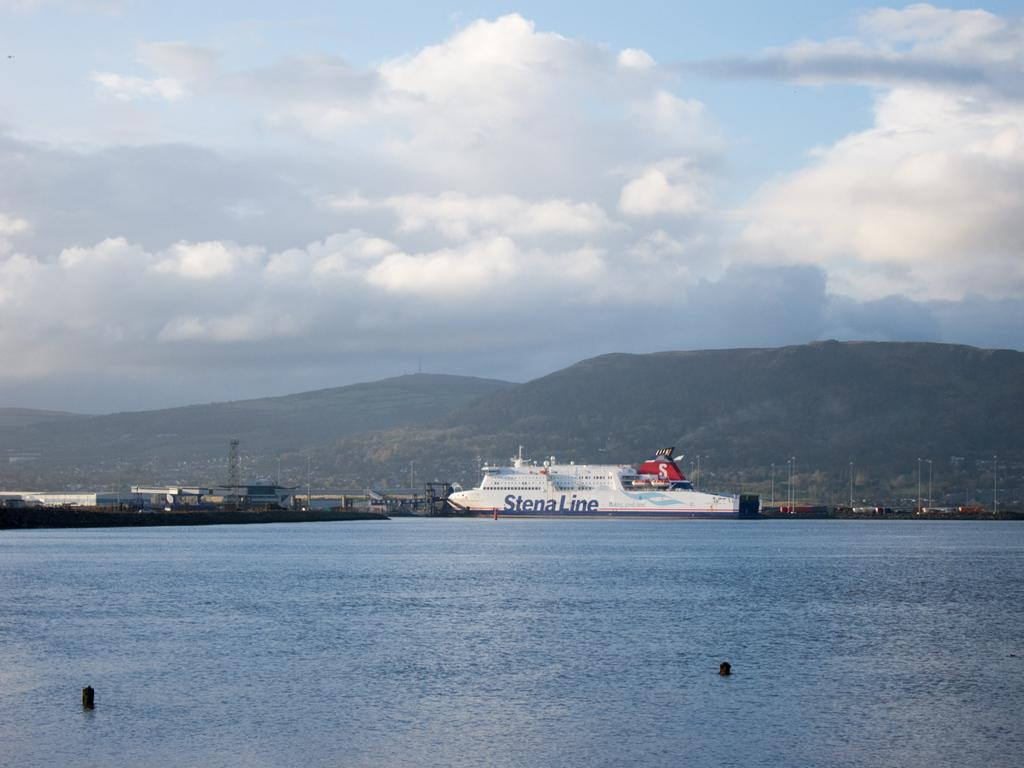What can be seen in the image? There are objects in the image, including a ship. What is the ship situated on or in? The ship is situated on or in water, which is visible in the image. What can be seen in the background of the image? In the background of the image, there are buildings, poles, hills, and the sky. Can you describe the sky in the image? The sky is visible in the background of the image, and there are clouds present. What type of carpenter is working on the yoke in the image? There is no carpenter or yoke present in the image; it features a ship on water with a background of buildings, poles, hills, and the sky. 